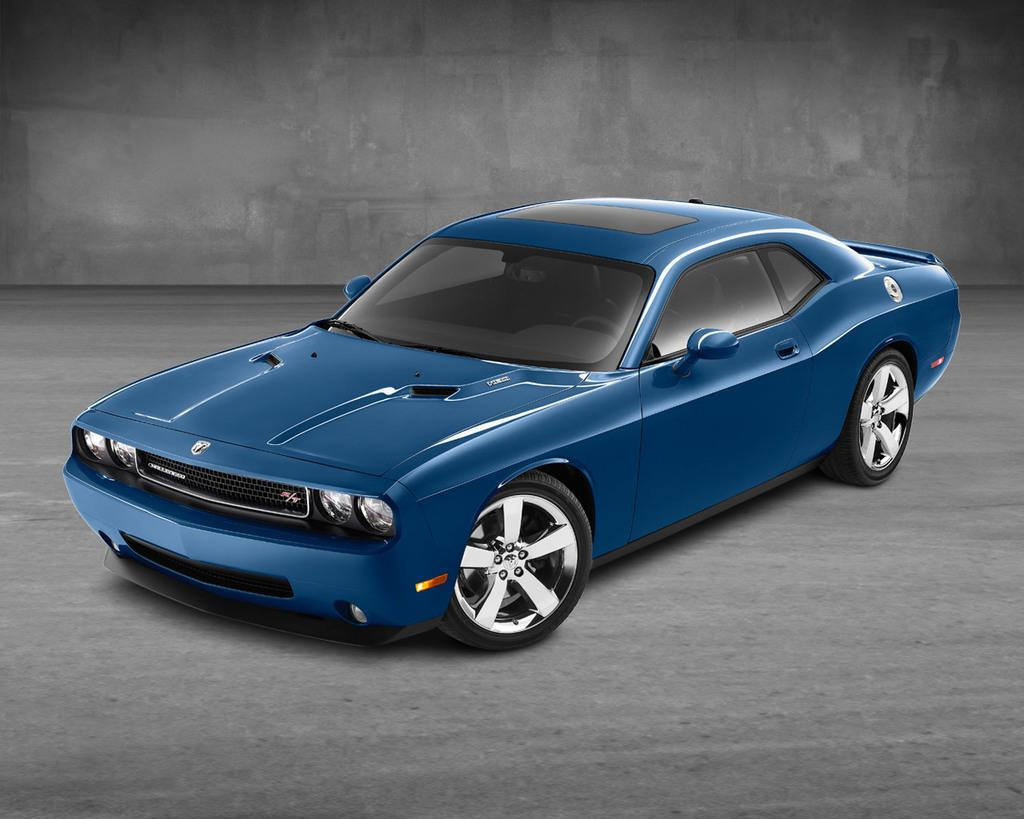What is the main subject of the image? The main subject of the image is a car. Where is the car located in the image? The car is on the road in the image. What can be seen in the background of the image? There is a wall in the background of the image. What type of loaf is being used as a weapon in the battle depicted in the image? There is no loaf or battle present in the image; it features a car on the road with a wall in the background. 